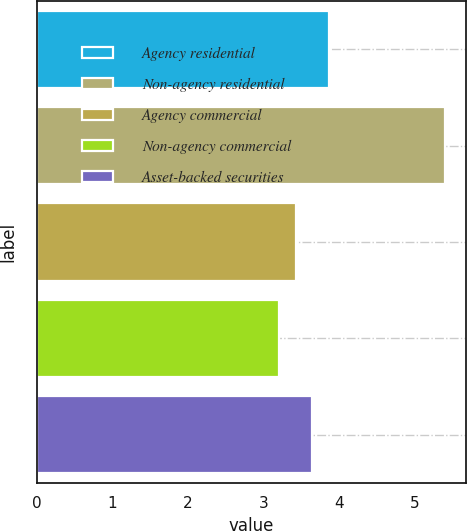<chart> <loc_0><loc_0><loc_500><loc_500><bar_chart><fcel>Agency residential<fcel>Non-agency residential<fcel>Agency commercial<fcel>Non-agency commercial<fcel>Asset-backed securities<nl><fcel>3.86<fcel>5.4<fcel>3.42<fcel>3.2<fcel>3.64<nl></chart> 